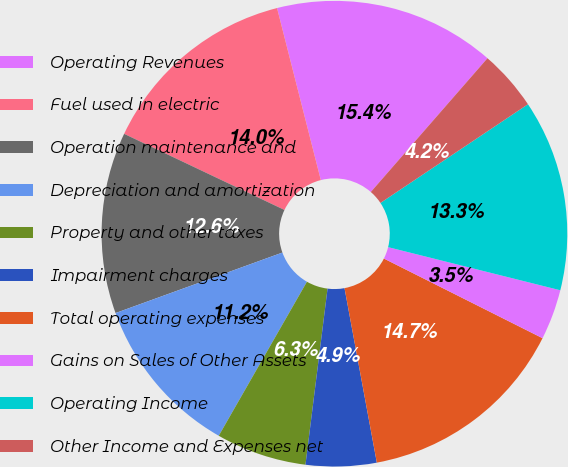Convert chart to OTSL. <chart><loc_0><loc_0><loc_500><loc_500><pie_chart><fcel>Operating Revenues<fcel>Fuel used in electric<fcel>Operation maintenance and<fcel>Depreciation and amortization<fcel>Property and other taxes<fcel>Impairment charges<fcel>Total operating expenses<fcel>Gains on Sales of Other Assets<fcel>Operating Income<fcel>Other Income and Expenses net<nl><fcel>15.38%<fcel>13.98%<fcel>12.59%<fcel>11.19%<fcel>6.29%<fcel>4.9%<fcel>14.68%<fcel>3.5%<fcel>13.29%<fcel>4.2%<nl></chart> 